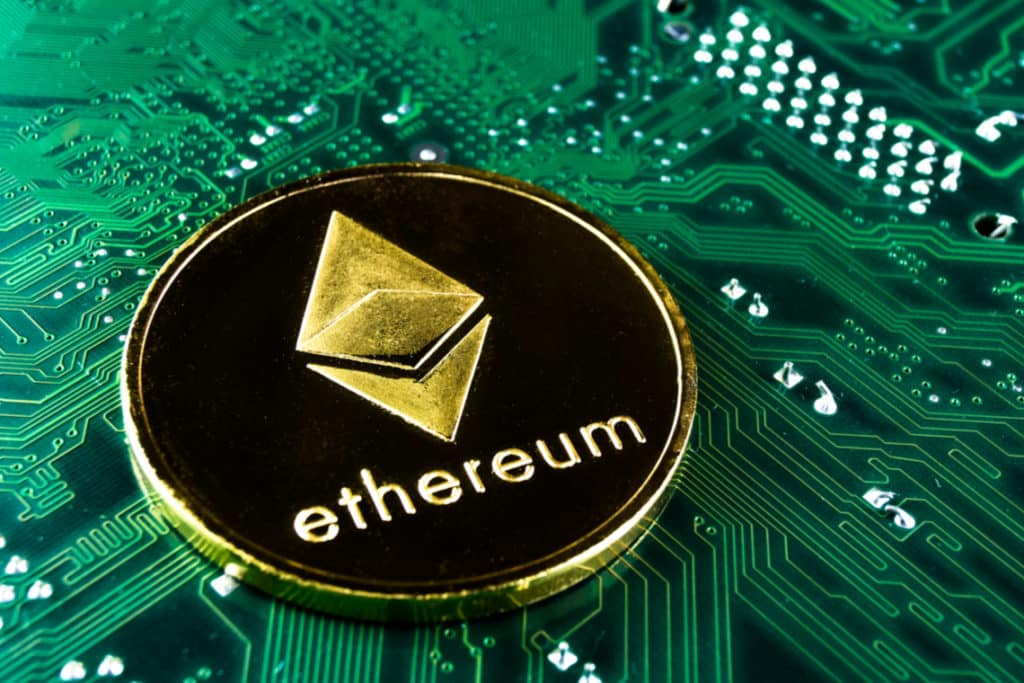Given the image, describe the implications for financial systems if blockchain technology becomes universally adopted. If blockchain technology, as symbolized by Ethereum and the circuit board, becomes universally adopted, financial systems would undergo a profound transformation. Transactions would become extraordinarily transparent, with every exchange and transfer being recorded on an immutable ledger accessible to all. This transparency could reduce fraud and corruption, as well as eliminate the need for intermediaries like banks, leading to faster and more cost-effective financial transactions. Smart contracts could automate and enforce agreements, further minimizing human error and enhancing trust in financial dealings. Moreover, the decentralized nature of blockchain would democratize finance, giving individuals more control over their assets and financial data. However, this shift would also pose challenges such as ensuring data privacy, the need for significant energy resources for maintaining blockchain networks, and navigating regulatory landscapes. 